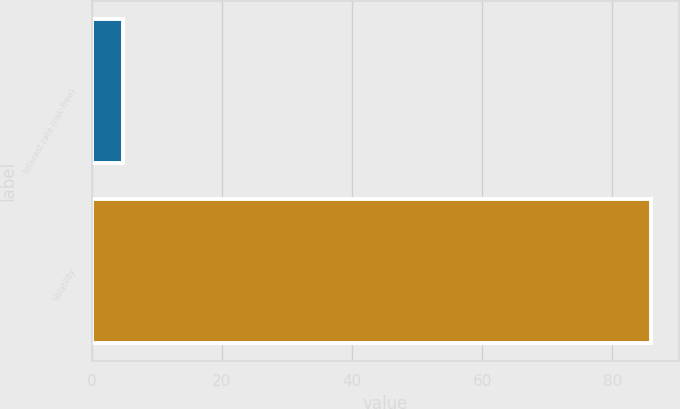Convert chart to OTSL. <chart><loc_0><loc_0><loc_500><loc_500><bar_chart><fcel>Interest rate (risk-free)<fcel>Volatility<nl><fcel>4.84<fcel>86<nl></chart> 